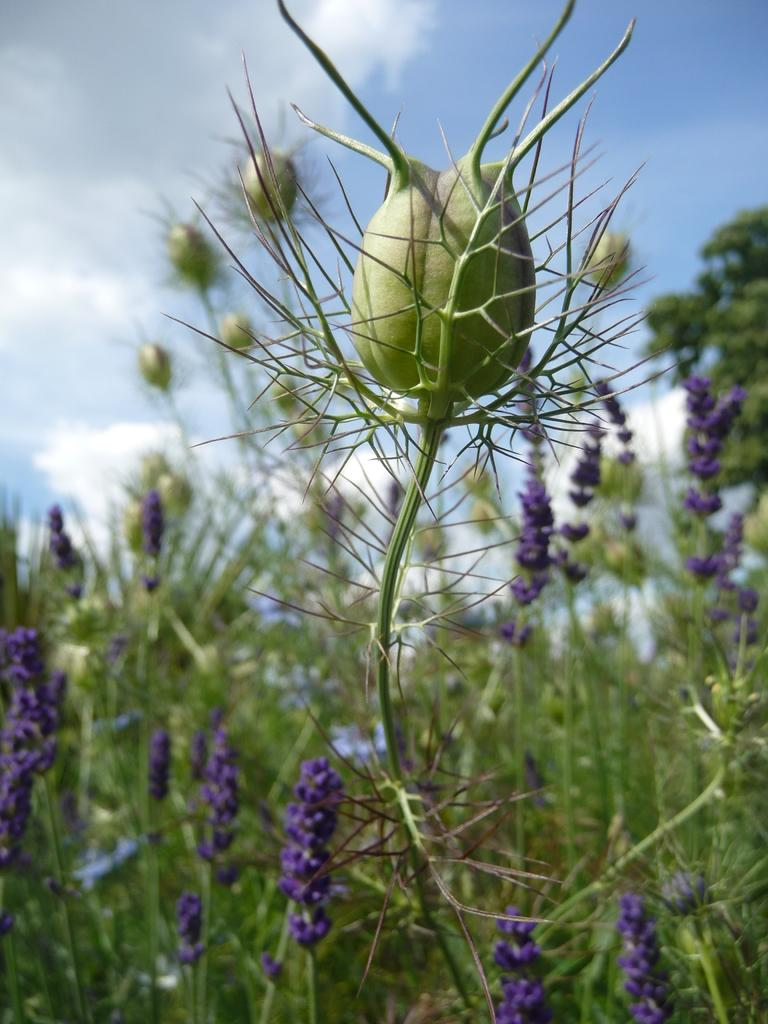What type of vegetation can be seen in the image? There are plants and trees in the image. What is visible in the background of the image? The sky is visible in the background of the image. How is the background of the image depicted? The background of the image is blurred. What type of brush is being used to paint the trees in the image? There is no indication in the image that the trees are being painted or that a brush is being used. 